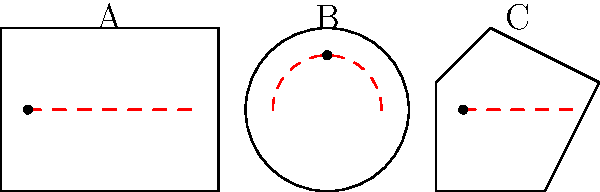As an independent artist focused on well-engineered sound, you're designing a recording studio. Which room shape (A, B, or C) would likely provide the most even sound distribution and minimize standing waves? To answer this question, let's analyze each room shape:

1. Room A (Rectangular):
   - Parallel walls can create standing waves and flutter echoes.
   - Has predictable modes, but can lead to uneven frequency response.

2. Room B (Circular):
   - Curved surfaces disperse sound more evenly.
   - Reduces parallel surface reflections and standing waves.
   - Can create a focusing effect at the center.

3. Room C (Irregular):
   - Non-parallel walls diffuse sound reflections.
   - Minimizes standing waves and flutter echoes.
   - Creates a more even frequency response throughout the room.

For a well-engineered sound:
- We want to minimize standing waves and flutter echoes.
- We need even sound distribution across frequencies.
- We should avoid focusing effects that create hot spots.

Room C (Irregular) best meets these criteria because:
1. Its non-parallel walls naturally diffuse sound.
2. It minimizes the formation of standing waves.
3. It provides a more even frequency response throughout the space.

While Room B (Circular) also has some advantages, it can create a focusing effect at the center, which is less desirable for even sound distribution.
Answer: C (Irregular shape) 